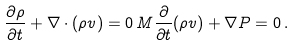<formula> <loc_0><loc_0><loc_500><loc_500>\frac { \partial \rho } { \partial t } + { \nabla } \cdot ( \rho { v } ) = 0 \, M \frac { \partial } { \partial t } ( \rho { v } ) + { \nabla } P = 0 \, .</formula> 